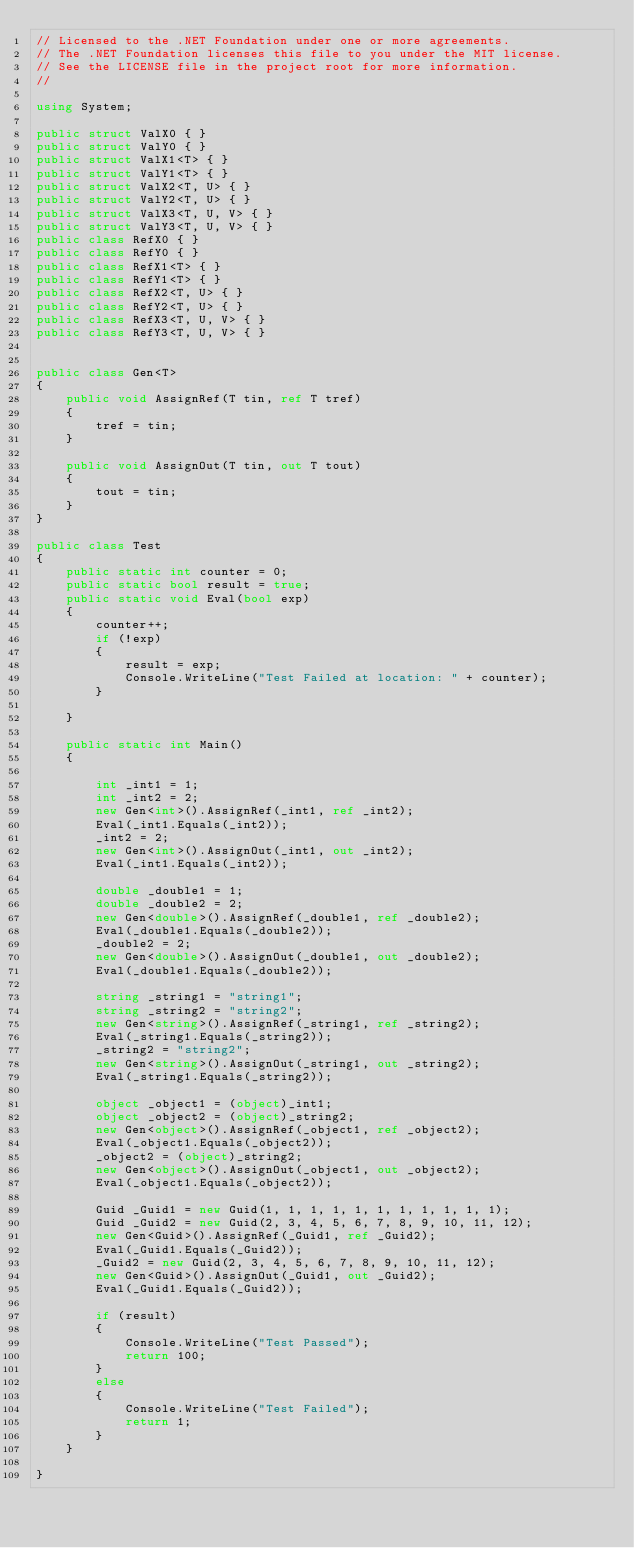<code> <loc_0><loc_0><loc_500><loc_500><_C#_>// Licensed to the .NET Foundation under one or more agreements.
// The .NET Foundation licenses this file to you under the MIT license.
// See the LICENSE file in the project root for more information.
//

using System;

public struct ValX0 { }
public struct ValY0 { }
public struct ValX1<T> { }
public struct ValY1<T> { }
public struct ValX2<T, U> { }
public struct ValY2<T, U> { }
public struct ValX3<T, U, V> { }
public struct ValY3<T, U, V> { }
public class RefX0 { }
public class RefY0 { }
public class RefX1<T> { }
public class RefY1<T> { }
public class RefX2<T, U> { }
public class RefY2<T, U> { }
public class RefX3<T, U, V> { }
public class RefY3<T, U, V> { }


public class Gen<T>
{
    public void AssignRef(T tin, ref T tref)
    {
        tref = tin;
    }

    public void AssignOut(T tin, out T tout)
    {
        tout = tin;
    }
}

public class Test
{
    public static int counter = 0;
    public static bool result = true;
    public static void Eval(bool exp)
    {
        counter++;
        if (!exp)
        {
            result = exp;
            Console.WriteLine("Test Failed at location: " + counter);
        }

    }

    public static int Main()
    {

        int _int1 = 1;
        int _int2 = 2;
        new Gen<int>().AssignRef(_int1, ref _int2);
        Eval(_int1.Equals(_int2));
        _int2 = 2;
        new Gen<int>().AssignOut(_int1, out _int2);
        Eval(_int1.Equals(_int2));

        double _double1 = 1;
        double _double2 = 2;
        new Gen<double>().AssignRef(_double1, ref _double2);
        Eval(_double1.Equals(_double2));
        _double2 = 2;
        new Gen<double>().AssignOut(_double1, out _double2);
        Eval(_double1.Equals(_double2));

        string _string1 = "string1";
        string _string2 = "string2";
        new Gen<string>().AssignRef(_string1, ref _string2);
        Eval(_string1.Equals(_string2));
        _string2 = "string2";
        new Gen<string>().AssignOut(_string1, out _string2);
        Eval(_string1.Equals(_string2));

        object _object1 = (object)_int1;
        object _object2 = (object)_string2;
        new Gen<object>().AssignRef(_object1, ref _object2);
        Eval(_object1.Equals(_object2));
        _object2 = (object)_string2;
        new Gen<object>().AssignOut(_object1, out _object2);
        Eval(_object1.Equals(_object2));

        Guid _Guid1 = new Guid(1, 1, 1, 1, 1, 1, 1, 1, 1, 1, 1);
        Guid _Guid2 = new Guid(2, 3, 4, 5, 6, 7, 8, 9, 10, 11, 12);
        new Gen<Guid>().AssignRef(_Guid1, ref _Guid2);
        Eval(_Guid1.Equals(_Guid2));
        _Guid2 = new Guid(2, 3, 4, 5, 6, 7, 8, 9, 10, 11, 12);
        new Gen<Guid>().AssignOut(_Guid1, out _Guid2);
        Eval(_Guid1.Equals(_Guid2));

        if (result)
        {
            Console.WriteLine("Test Passed");
            return 100;
        }
        else
        {
            Console.WriteLine("Test Failed");
            return 1;
        }
    }

}
</code> 